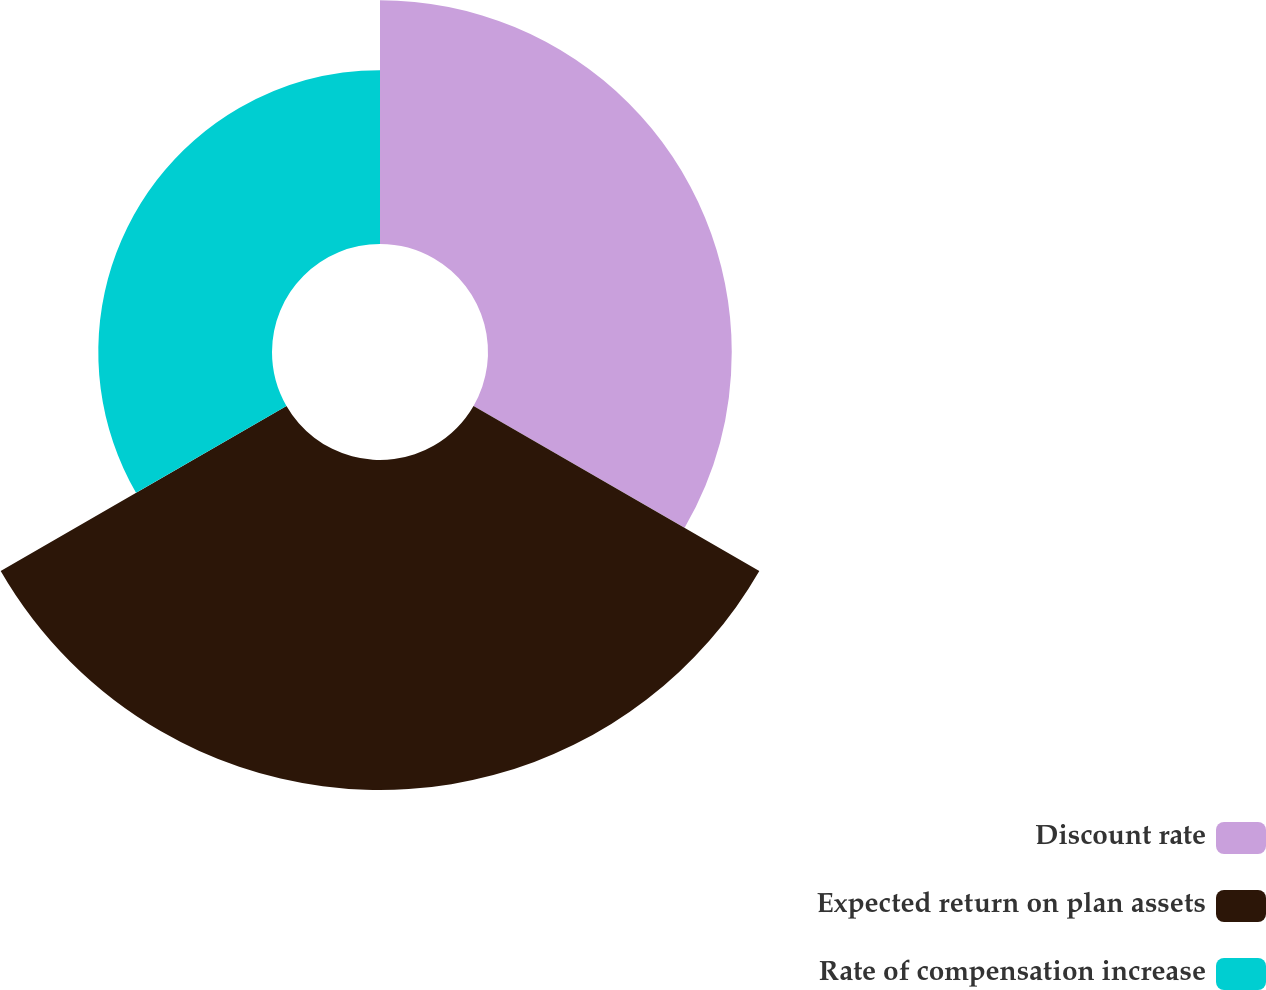Convert chart. <chart><loc_0><loc_0><loc_500><loc_500><pie_chart><fcel>Discount rate<fcel>Expected return on plan assets<fcel>Rate of compensation increase<nl><fcel>32.61%<fcel>44.15%<fcel>23.24%<nl></chart> 